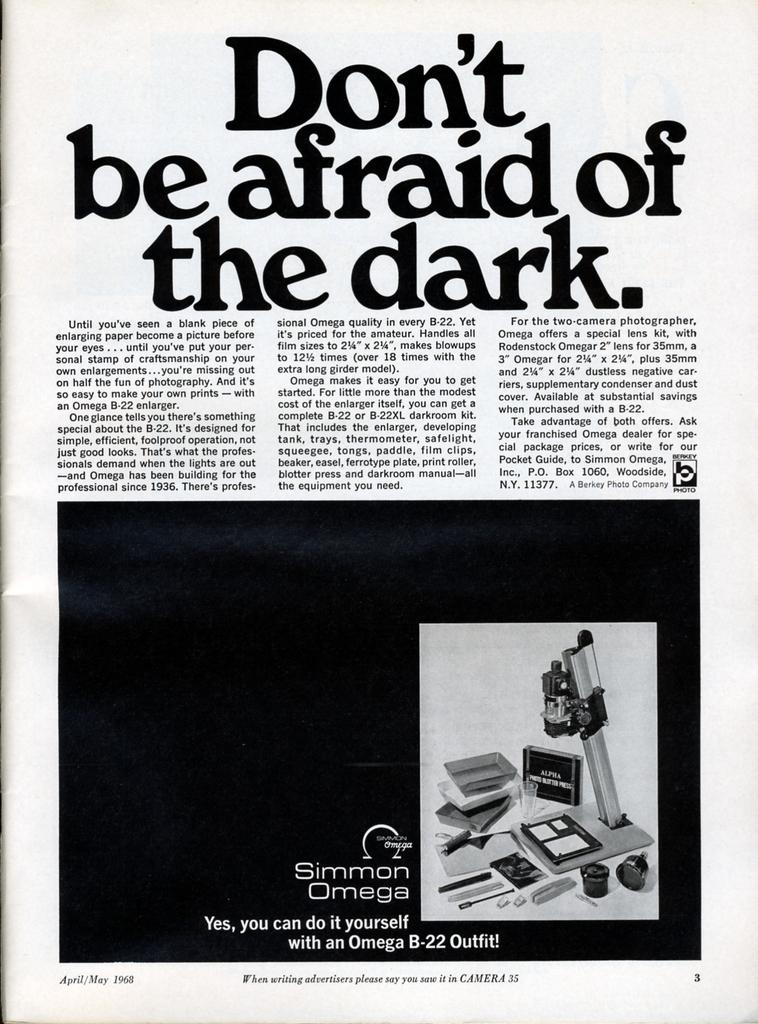<image>
Offer a succinct explanation of the picture presented. A vintage advertisement for Simmon Omega tells you not to be afraid of the dark. 